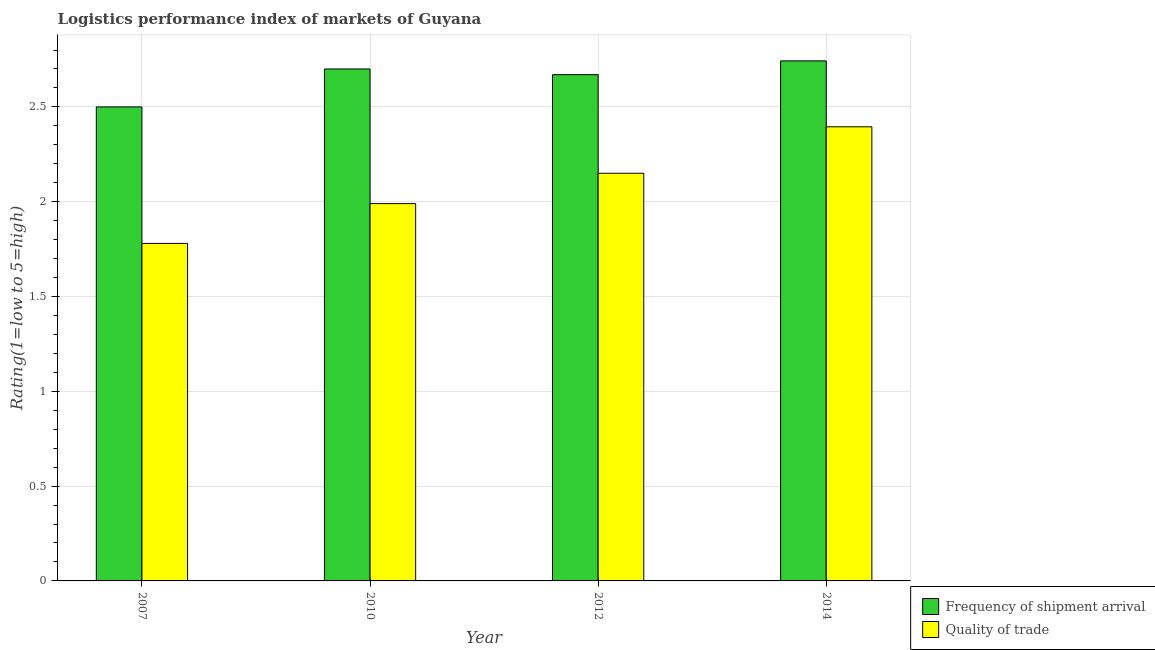Are the number of bars on each tick of the X-axis equal?
Provide a succinct answer. Yes. How many bars are there on the 4th tick from the left?
Your response must be concise. 2. What is the label of the 1st group of bars from the left?
Offer a very short reply. 2007. In how many cases, is the number of bars for a given year not equal to the number of legend labels?
Keep it short and to the point. 0. What is the lpi of frequency of shipment arrival in 2012?
Ensure brevity in your answer.  2.67. Across all years, what is the maximum lpi of frequency of shipment arrival?
Provide a short and direct response. 2.74. Across all years, what is the minimum lpi quality of trade?
Your response must be concise. 1.78. In which year was the lpi of frequency of shipment arrival maximum?
Your answer should be very brief. 2014. In which year was the lpi quality of trade minimum?
Your answer should be very brief. 2007. What is the total lpi of frequency of shipment arrival in the graph?
Keep it short and to the point. 10.61. What is the difference between the lpi quality of trade in 2007 and that in 2012?
Provide a succinct answer. -0.37. What is the difference between the lpi of frequency of shipment arrival in 2012 and the lpi quality of trade in 2014?
Offer a terse response. -0.07. What is the average lpi quality of trade per year?
Your answer should be very brief. 2.08. What is the ratio of the lpi quality of trade in 2010 to that in 2012?
Offer a terse response. 0.93. Is the lpi of frequency of shipment arrival in 2010 less than that in 2014?
Your answer should be compact. Yes. Is the difference between the lpi of frequency of shipment arrival in 2007 and 2014 greater than the difference between the lpi quality of trade in 2007 and 2014?
Offer a very short reply. No. What is the difference between the highest and the second highest lpi quality of trade?
Keep it short and to the point. 0.25. What is the difference between the highest and the lowest lpi of frequency of shipment arrival?
Provide a short and direct response. 0.24. Is the sum of the lpi quality of trade in 2007 and 2010 greater than the maximum lpi of frequency of shipment arrival across all years?
Make the answer very short. Yes. What does the 2nd bar from the left in 2012 represents?
Make the answer very short. Quality of trade. What does the 2nd bar from the right in 2010 represents?
Ensure brevity in your answer.  Frequency of shipment arrival. How many bars are there?
Offer a very short reply. 8. Are all the bars in the graph horizontal?
Your response must be concise. No. What is the difference between two consecutive major ticks on the Y-axis?
Offer a terse response. 0.5. Are the values on the major ticks of Y-axis written in scientific E-notation?
Keep it short and to the point. No. Does the graph contain any zero values?
Provide a succinct answer. No. Does the graph contain grids?
Provide a succinct answer. Yes. How many legend labels are there?
Provide a short and direct response. 2. How are the legend labels stacked?
Give a very brief answer. Vertical. What is the title of the graph?
Provide a succinct answer. Logistics performance index of markets of Guyana. Does "Borrowers" appear as one of the legend labels in the graph?
Ensure brevity in your answer.  No. What is the label or title of the Y-axis?
Ensure brevity in your answer.  Rating(1=low to 5=high). What is the Rating(1=low to 5=high) in Frequency of shipment arrival in 2007?
Offer a terse response. 2.5. What is the Rating(1=low to 5=high) of Quality of trade in 2007?
Ensure brevity in your answer.  1.78. What is the Rating(1=low to 5=high) in Frequency of shipment arrival in 2010?
Offer a very short reply. 2.7. What is the Rating(1=low to 5=high) in Quality of trade in 2010?
Your response must be concise. 1.99. What is the Rating(1=low to 5=high) of Frequency of shipment arrival in 2012?
Your response must be concise. 2.67. What is the Rating(1=low to 5=high) in Quality of trade in 2012?
Your answer should be compact. 2.15. What is the Rating(1=low to 5=high) of Frequency of shipment arrival in 2014?
Your response must be concise. 2.74. What is the Rating(1=low to 5=high) in Quality of trade in 2014?
Give a very brief answer. 2.4. Across all years, what is the maximum Rating(1=low to 5=high) in Frequency of shipment arrival?
Provide a succinct answer. 2.74. Across all years, what is the maximum Rating(1=low to 5=high) of Quality of trade?
Ensure brevity in your answer.  2.4. Across all years, what is the minimum Rating(1=low to 5=high) of Quality of trade?
Your answer should be very brief. 1.78. What is the total Rating(1=low to 5=high) of Frequency of shipment arrival in the graph?
Provide a short and direct response. 10.61. What is the total Rating(1=low to 5=high) of Quality of trade in the graph?
Your response must be concise. 8.32. What is the difference between the Rating(1=low to 5=high) in Quality of trade in 2007 and that in 2010?
Offer a terse response. -0.21. What is the difference between the Rating(1=low to 5=high) in Frequency of shipment arrival in 2007 and that in 2012?
Ensure brevity in your answer.  -0.17. What is the difference between the Rating(1=low to 5=high) in Quality of trade in 2007 and that in 2012?
Provide a short and direct response. -0.37. What is the difference between the Rating(1=low to 5=high) of Frequency of shipment arrival in 2007 and that in 2014?
Offer a very short reply. -0.24. What is the difference between the Rating(1=low to 5=high) in Quality of trade in 2007 and that in 2014?
Your answer should be very brief. -0.62. What is the difference between the Rating(1=low to 5=high) of Quality of trade in 2010 and that in 2012?
Your answer should be very brief. -0.16. What is the difference between the Rating(1=low to 5=high) of Frequency of shipment arrival in 2010 and that in 2014?
Make the answer very short. -0.04. What is the difference between the Rating(1=low to 5=high) of Quality of trade in 2010 and that in 2014?
Give a very brief answer. -0.41. What is the difference between the Rating(1=low to 5=high) of Frequency of shipment arrival in 2012 and that in 2014?
Offer a terse response. -0.07. What is the difference between the Rating(1=low to 5=high) in Quality of trade in 2012 and that in 2014?
Make the answer very short. -0.25. What is the difference between the Rating(1=low to 5=high) in Frequency of shipment arrival in 2007 and the Rating(1=low to 5=high) in Quality of trade in 2010?
Offer a very short reply. 0.51. What is the difference between the Rating(1=low to 5=high) in Frequency of shipment arrival in 2007 and the Rating(1=low to 5=high) in Quality of trade in 2014?
Provide a short and direct response. 0.1. What is the difference between the Rating(1=low to 5=high) in Frequency of shipment arrival in 2010 and the Rating(1=low to 5=high) in Quality of trade in 2012?
Your answer should be very brief. 0.55. What is the difference between the Rating(1=low to 5=high) of Frequency of shipment arrival in 2010 and the Rating(1=low to 5=high) of Quality of trade in 2014?
Give a very brief answer. 0.3. What is the difference between the Rating(1=low to 5=high) in Frequency of shipment arrival in 2012 and the Rating(1=low to 5=high) in Quality of trade in 2014?
Offer a very short reply. 0.27. What is the average Rating(1=low to 5=high) in Frequency of shipment arrival per year?
Ensure brevity in your answer.  2.65. What is the average Rating(1=low to 5=high) of Quality of trade per year?
Keep it short and to the point. 2.08. In the year 2007, what is the difference between the Rating(1=low to 5=high) in Frequency of shipment arrival and Rating(1=low to 5=high) in Quality of trade?
Provide a short and direct response. 0.72. In the year 2010, what is the difference between the Rating(1=low to 5=high) in Frequency of shipment arrival and Rating(1=low to 5=high) in Quality of trade?
Give a very brief answer. 0.71. In the year 2012, what is the difference between the Rating(1=low to 5=high) in Frequency of shipment arrival and Rating(1=low to 5=high) in Quality of trade?
Your response must be concise. 0.52. In the year 2014, what is the difference between the Rating(1=low to 5=high) of Frequency of shipment arrival and Rating(1=low to 5=high) of Quality of trade?
Provide a succinct answer. 0.35. What is the ratio of the Rating(1=low to 5=high) of Frequency of shipment arrival in 2007 to that in 2010?
Your answer should be compact. 0.93. What is the ratio of the Rating(1=low to 5=high) of Quality of trade in 2007 to that in 2010?
Provide a short and direct response. 0.89. What is the ratio of the Rating(1=low to 5=high) in Frequency of shipment arrival in 2007 to that in 2012?
Ensure brevity in your answer.  0.94. What is the ratio of the Rating(1=low to 5=high) in Quality of trade in 2007 to that in 2012?
Your answer should be very brief. 0.83. What is the ratio of the Rating(1=low to 5=high) in Frequency of shipment arrival in 2007 to that in 2014?
Provide a succinct answer. 0.91. What is the ratio of the Rating(1=low to 5=high) of Quality of trade in 2007 to that in 2014?
Offer a very short reply. 0.74. What is the ratio of the Rating(1=low to 5=high) of Frequency of shipment arrival in 2010 to that in 2012?
Your answer should be very brief. 1.01. What is the ratio of the Rating(1=low to 5=high) in Quality of trade in 2010 to that in 2012?
Give a very brief answer. 0.93. What is the ratio of the Rating(1=low to 5=high) in Frequency of shipment arrival in 2010 to that in 2014?
Your answer should be compact. 0.98. What is the ratio of the Rating(1=low to 5=high) in Quality of trade in 2010 to that in 2014?
Your answer should be very brief. 0.83. What is the ratio of the Rating(1=low to 5=high) of Frequency of shipment arrival in 2012 to that in 2014?
Your response must be concise. 0.97. What is the ratio of the Rating(1=low to 5=high) in Quality of trade in 2012 to that in 2014?
Offer a very short reply. 0.9. What is the difference between the highest and the second highest Rating(1=low to 5=high) of Frequency of shipment arrival?
Your answer should be compact. 0.04. What is the difference between the highest and the second highest Rating(1=low to 5=high) in Quality of trade?
Give a very brief answer. 0.25. What is the difference between the highest and the lowest Rating(1=low to 5=high) of Frequency of shipment arrival?
Give a very brief answer. 0.24. What is the difference between the highest and the lowest Rating(1=low to 5=high) of Quality of trade?
Your answer should be very brief. 0.62. 